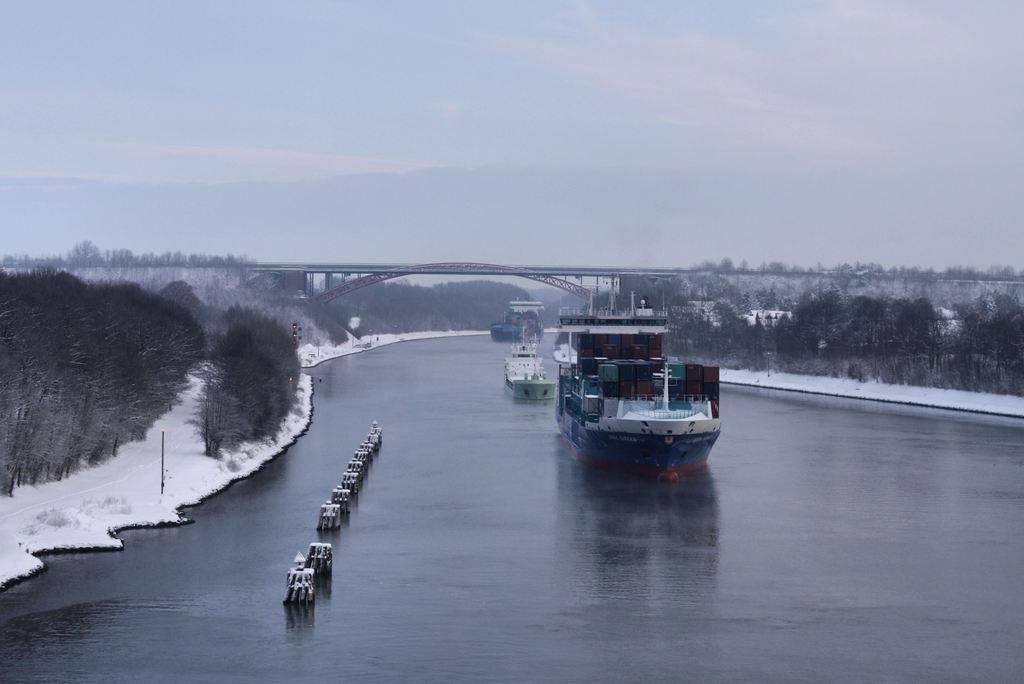What is the main subject of the image? The main subject of the image is ships on water. What type of natural environment can be seen in the image? There are trees visible in the image, indicating a natural environment. What is the body of water in the image used for? The presence of ships suggests that the body of water is used for transportation or shipping. What structure can be seen in the image? There is a bridge in the image. What is visible in the background of the image? The sky is visible in the background of the image, with clouds present. Can you tell me how many cellars are visible in the image? There are no cellars present in the image; it features ships on water, trees, a bridge, and a sky with clouds. What type of brake is used by the ships in the image? Ships do not have brakes like vehicles; they use anchors or other methods to slow down or stop. 